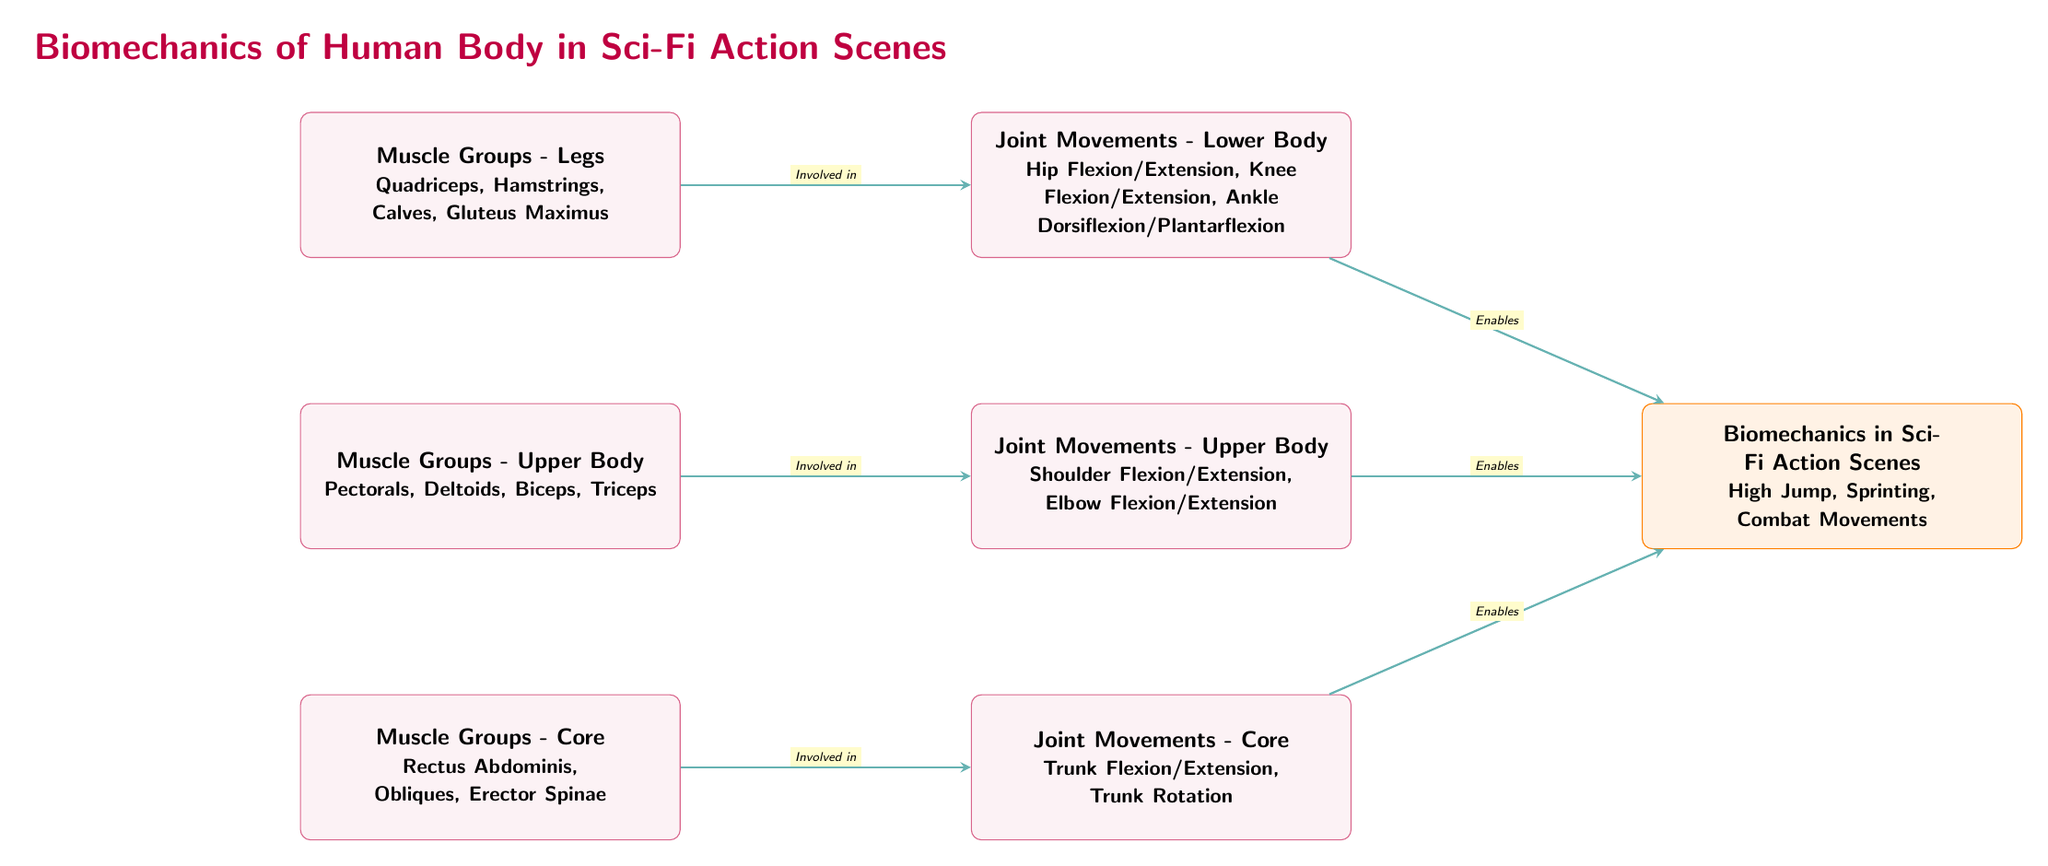What are the muscle groups in the legs? The diagram lists the muscle groups in the legs, which include Quadriceps, Hamstrings, Calves, and Gluteus Maximus.
Answer: Quadriceps, Hamstrings, Calves, Gluteus Maximus What type of joint movement is related to the upper body? The diagram specifies the joint movements associated with the upper body, which are Shoulder Flexion/Extension and Elbow Flexion/Extension.
Answer: Shoulder Flexion/Extension, Elbow Flexion/Extension How many muscle groups are mentioned for the core? The diagram outlines the muscle groups in the core, which include Rectus Abdominis, Obliques, and Erector Spinae. Thus, there are three muscle groups mentioned.
Answer: 3 What enabled biomechanics in sci-fi action scenes? The diagram indicates that the joint movements in the legs, upper body, and core all enable the biomechanics seen in sci-fi action scenes. This implies that multiple joint movements collectively contribute to biomechanics.
Answer: Joint movements What joint movement is associated with the legs? The diagram provides specific joint movements linked to the legs, including Hip Flexion/Extension, Knee Flexion/Extension, and Ankle Dorsiflexion/Plantarflexion.
Answer: Hip Flexion/Extension, Knee Flexion/Extension, Ankle Dorsiflexion/Plantarflexion Which muscle group is responsible for sprinting biomechanics? The diagram indicates that muscle groups and joint movements contribute to biomechanics in high-intensity activities like sprinting. Among the muscle groups, the legs are vital for sprinting biomechanics.
Answer: Legs What is the connection between muscle groups and joint movements? According to the diagram, each set of muscle groups is linked to specific joint movements, indicating that muscle activity in these groups is fundamental to enabling those movements.
Answer: Involved in How many main categories of muscle groups are highlighted? The diagram presents three main categories of muscle groups, which are Legs, Upper Body, and Core.
Answer: 3 